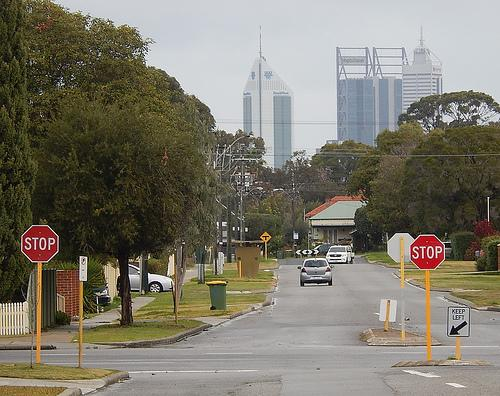Talk about the fencing components present in the image and their positioning. A white picket fence appears on the side of the street near the stop sign, and a brick fence can be seen under tall trees. Briefly explain the distinctive signs present in the image and their particular characteristics. The image shows a red and yellow stop sign, a "keep left" sign in black and white, and a yellow sign with a black symbol. Describe the most prominent natural element in the image and its position. A big green tree stands tall on the side of the street, overshadowing its surroundings with its lush foliage. Pick two prominent objects on the image with the unusual color combinations and explain their appearances. A red and yellow stop sign stands near a street sign, and a green trash can with a yellow lid is placed next to the curb. Mention the primary object located on the left and right side of the street, and describe their appearances. On the left, there is a stop sign with a yellow pole, and on the right, there is a stop sign attached to a street sign, both featuring red octagonal shapes. Describe the tallest man-made structures visible in the image. Skyscrapers can be seen peaking over the horizon behind the trees, adding a sense of grandeur to the scene. Create a brief caption for the image that captures the overall theme of the scene. Stop signs, cars, and trees line a busy street, creating a harmonious blend of infrastructure and nature. Mention any street signs present in the image and describe their features. There's a black and white rectangular sign that says "keep left" and a white sign with an arrow, as well as stop signs mounted on yellow poles. Describe the scene happening on the side of the street that involves a trash can. There's a green and yellow trash can with a yellow lid situated on the side of the street near the curb, possibly awaiting pickup. Identify two different types of vehicles on the road and briefly describe them. There's a gray car driving down the street, and a white van following behind it, both appearing to be in motion. 